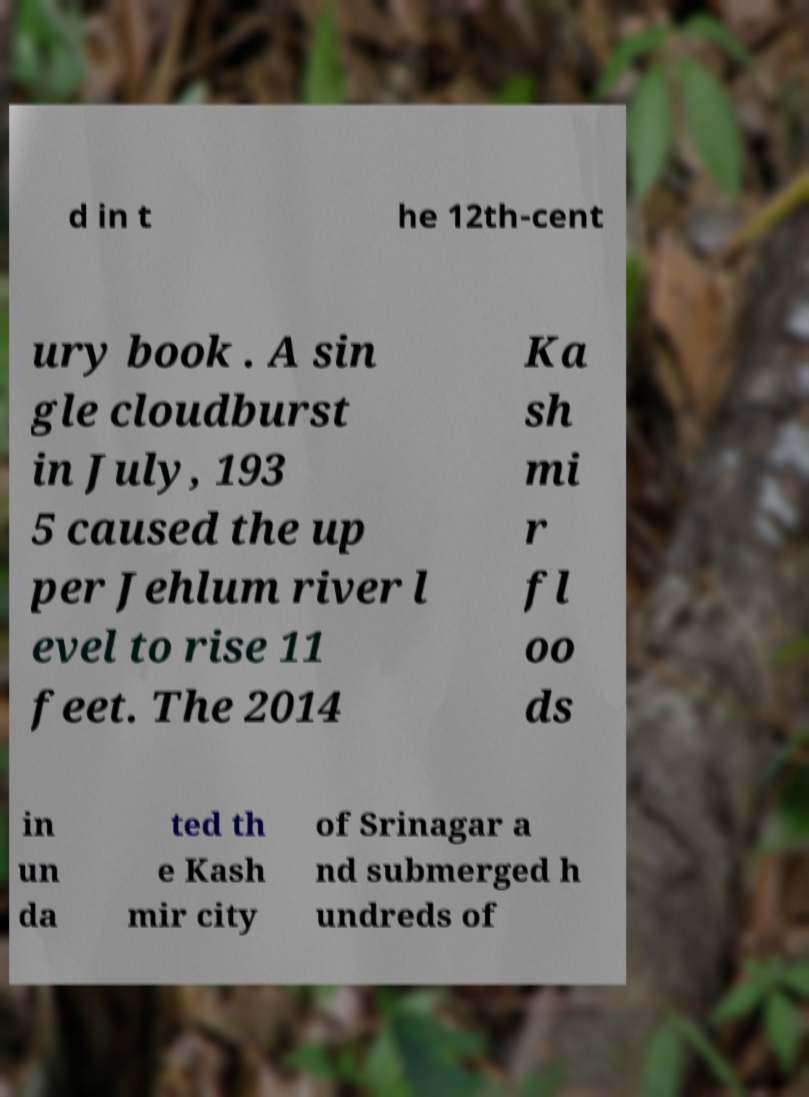Please identify and transcribe the text found in this image. d in t he 12th-cent ury book . A sin gle cloudburst in July, 193 5 caused the up per Jehlum river l evel to rise 11 feet. The 2014 Ka sh mi r fl oo ds in un da ted th e Kash mir city of Srinagar a nd submerged h undreds of 